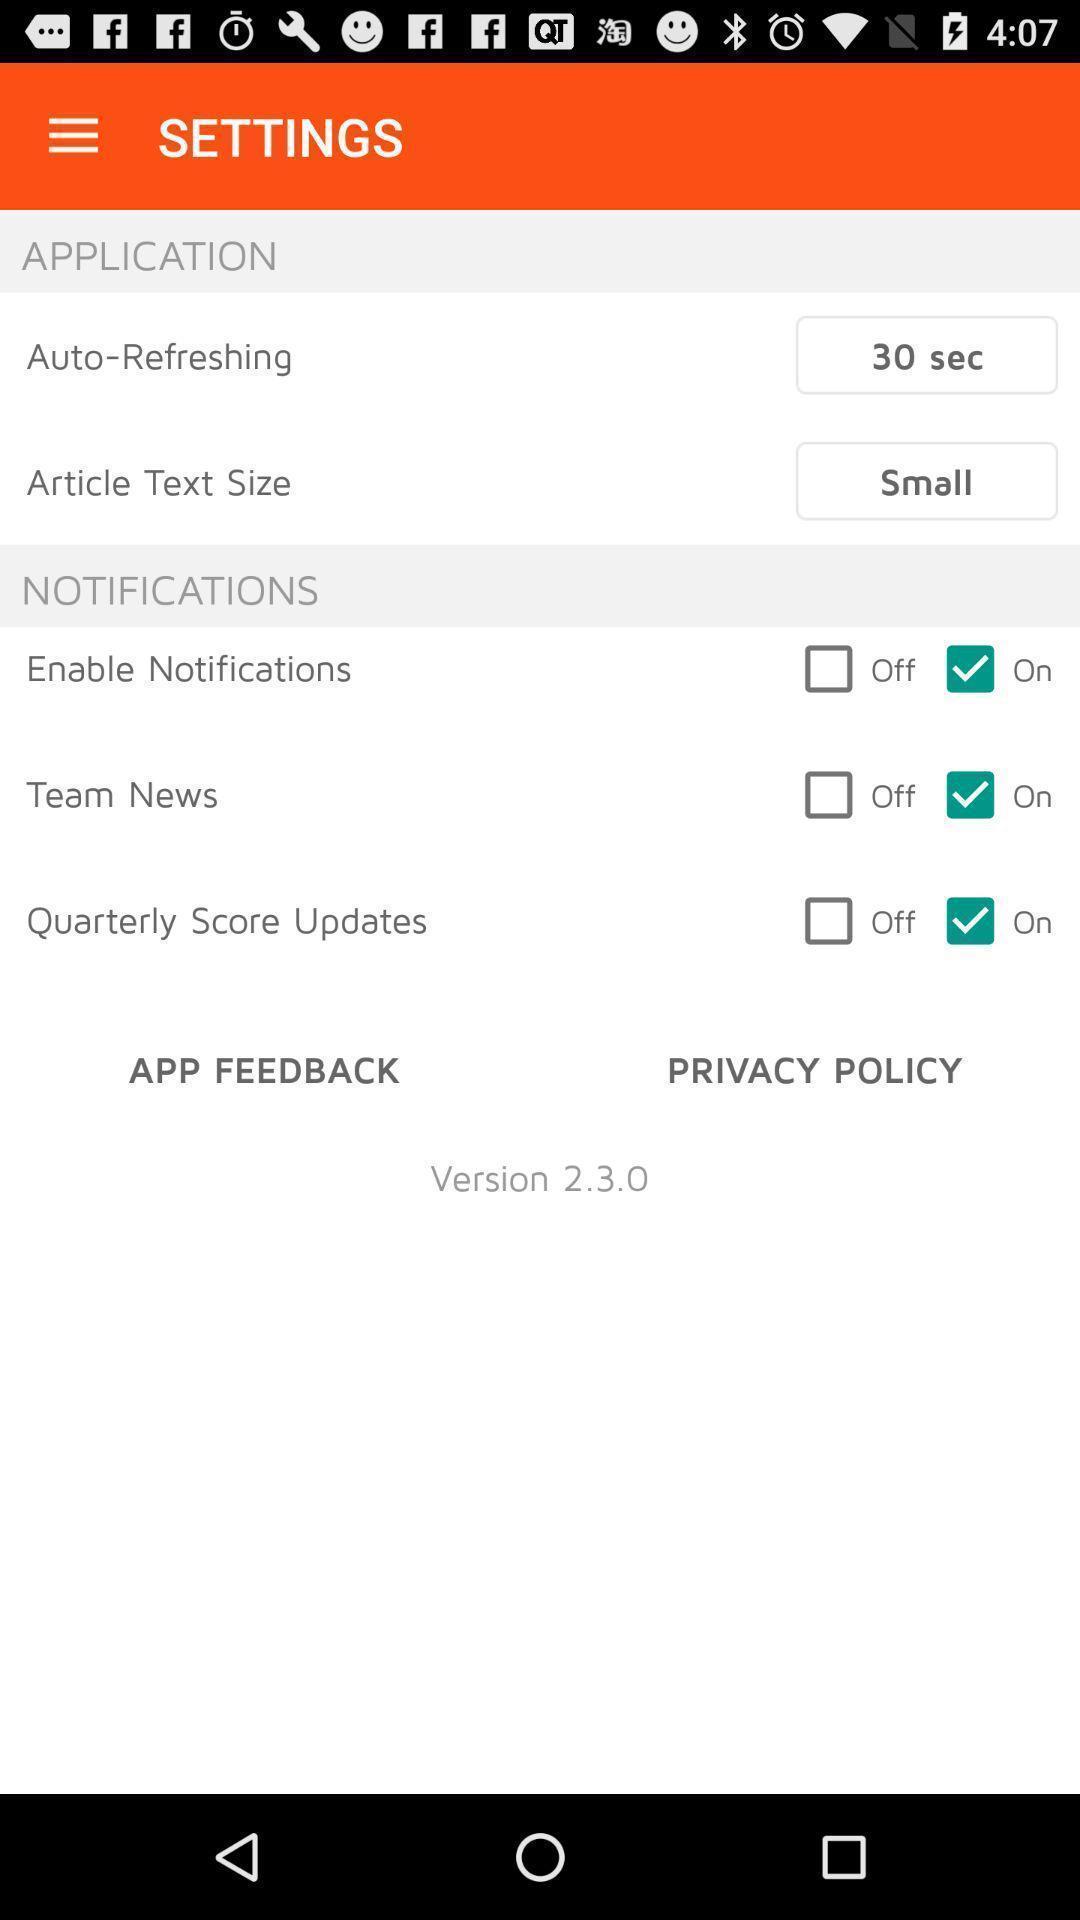What details can you identify in this image? Screen showing settings page. 